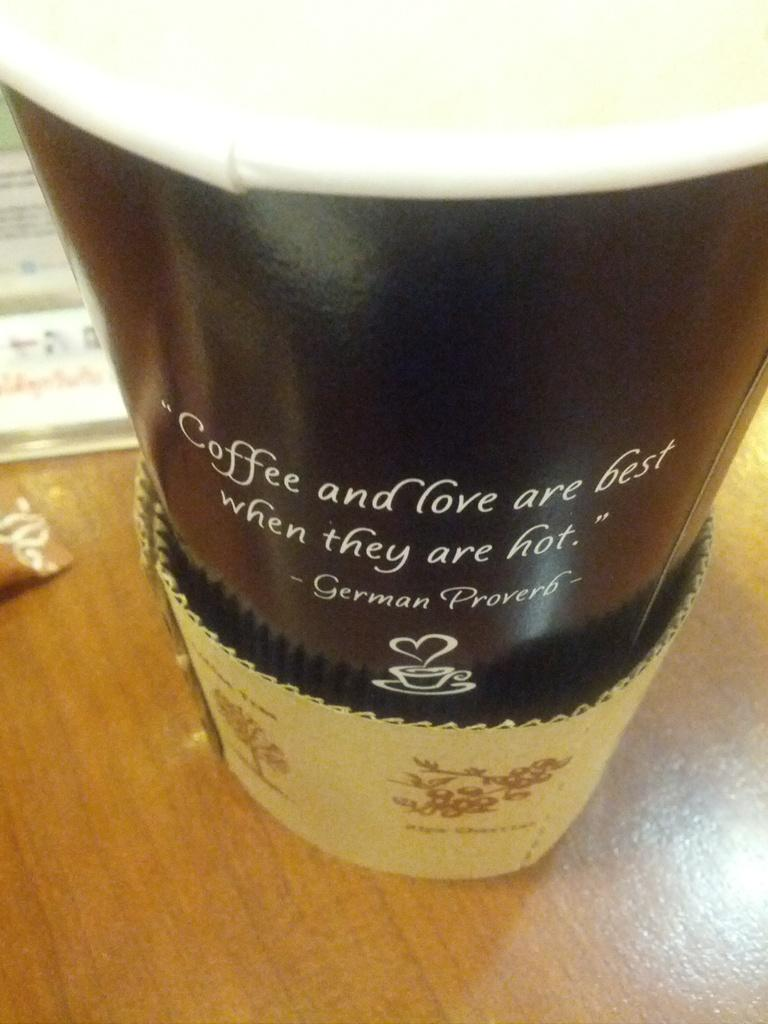<image>
Render a clear and concise summary of the photo. a close up of a cup with words Coffee and Love on the outside 